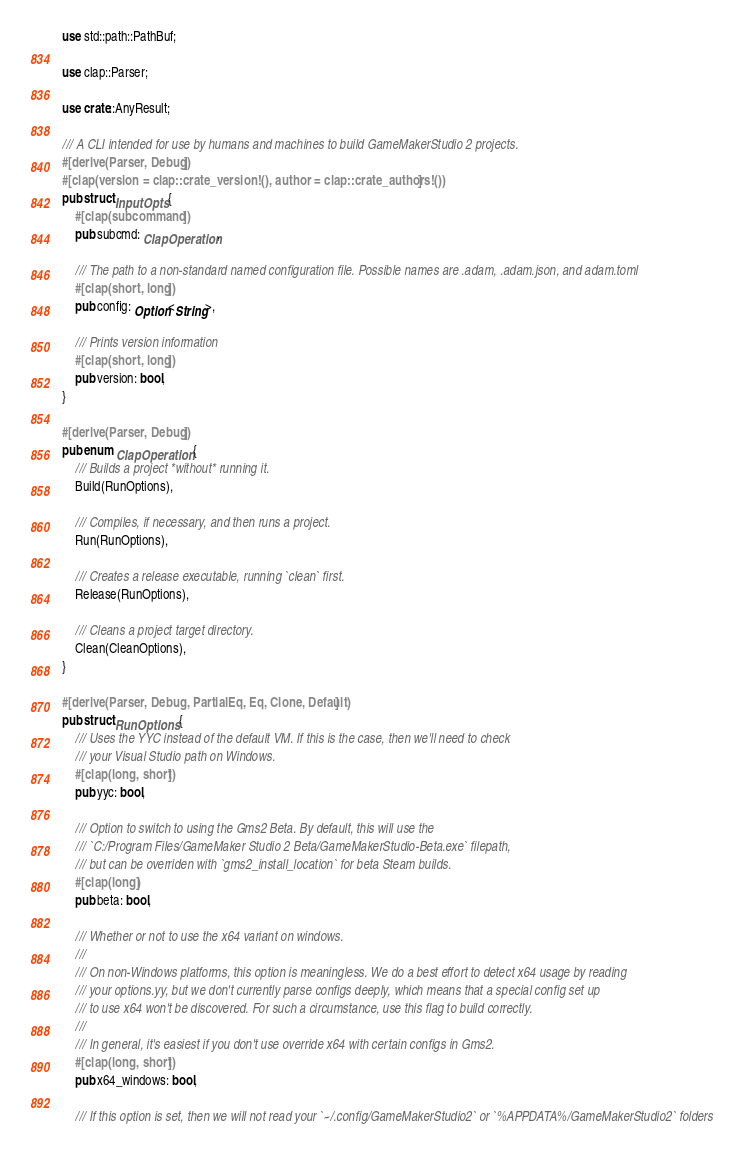Convert code to text. <code><loc_0><loc_0><loc_500><loc_500><_Rust_>use std::path::PathBuf;

use clap::Parser;

use crate::AnyResult;

/// A CLI intended for use by humans and machines to build GameMakerStudio 2 projects.
#[derive(Parser, Debug)]
#[clap(version = clap::crate_version!(), author = clap::crate_authors!())]
pub struct InputOpts {
    #[clap(subcommand)]
    pub subcmd: ClapOperation,

    /// The path to a non-standard named configuration file. Possible names are .adam, .adam.json, and adam.toml
    #[clap(short, long)]
    pub config: Option<String>,

    /// Prints version information
    #[clap(short, long)]
    pub version: bool,
}

#[derive(Parser, Debug)]
pub enum ClapOperation {
    /// Builds a project *without* running it.
    Build(RunOptions),

    /// Compiles, if necessary, and then runs a project.
    Run(RunOptions),

    /// Creates a release executable, running `clean` first.
    Release(RunOptions),

    /// Cleans a project target directory.
    Clean(CleanOptions),
}

#[derive(Parser, Debug, PartialEq, Eq, Clone, Default)]
pub struct RunOptions {
    /// Uses the YYC instead of the default VM. If this is the case, then we'll need to check
    /// your Visual Studio path on Windows.
    #[clap(long, short)]
    pub yyc: bool,

    /// Option to switch to using the Gms2 Beta. By default, this will use the
    /// `C:/Program Files/GameMaker Studio 2 Beta/GameMakerStudio-Beta.exe` filepath,
    /// but can be overriden with `gms2_install_location` for beta Steam builds.
    #[clap(long)]
    pub beta: bool,

    /// Whether or not to use the x64 variant on windows.
    ///
    /// On non-Windows platforms, this option is meaningless. We do a best effort to detect x64 usage by reading
    /// your options.yy, but we don't currently parse configs deeply, which means that a special config set up
    /// to use x64 won't be discovered. For such a circumstance, use this flag to build correctly.
    ///
    /// In general, it's easiest if you don't use override x64 with certain configs in Gms2.
    #[clap(long, short)]
    pub x64_windows: bool,

    /// If this option is set, then we will not read your `~/.config/GameMakerStudio2` or `%APPDATA%/GameMakerStudio2` folders</code> 